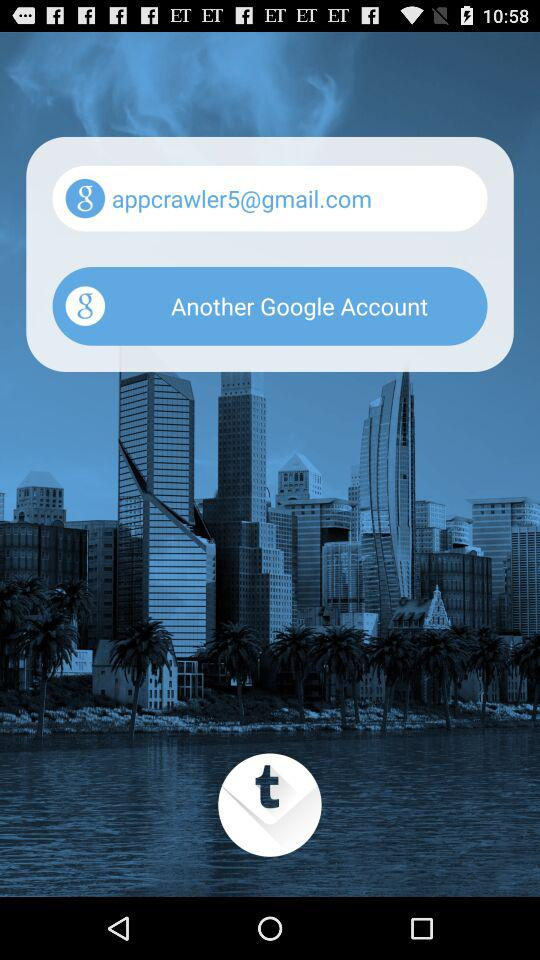What is the name of the application?
When the provided information is insufficient, respond with <no answer>. <no answer> 